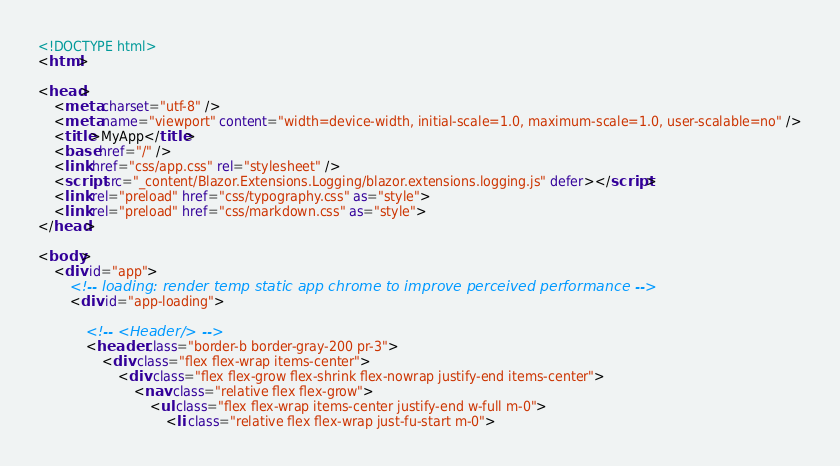<code> <loc_0><loc_0><loc_500><loc_500><_HTML_><!DOCTYPE html>
<html>

<head>
    <meta charset="utf-8" />
    <meta name="viewport" content="width=device-width, initial-scale=1.0, maximum-scale=1.0, user-scalable=no" />
    <title>MyApp</title>
    <base href="/" />
    <link href="css/app.css" rel="stylesheet" />
    <script src="_content/Blazor.Extensions.Logging/blazor.extensions.logging.js" defer></script>
    <link rel="preload" href="css/typography.css" as="style">
    <link rel="preload" href="css/markdown.css" as="style">
</head>

<body>
    <div id="app">
        <!-- loading: render temp static app chrome to improve perceived performance -->
        <div id="app-loading">

            <!-- <Header/> -->
            <header class="border-b border-gray-200 pr-3">
                <div class="flex flex-wrap items-center">
                    <div class="flex flex-grow flex-shrink flex-nowrap justify-end items-center">
                        <nav class="relative flex flex-grow">
                            <ul class="flex flex-wrap items-center justify-end w-full m-0">
                                <li class="relative flex flex-wrap just-fu-start m-0"></code> 